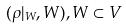Convert formula to latex. <formula><loc_0><loc_0><loc_500><loc_500>( \rho | _ { W } , W ) , W \subset V</formula> 